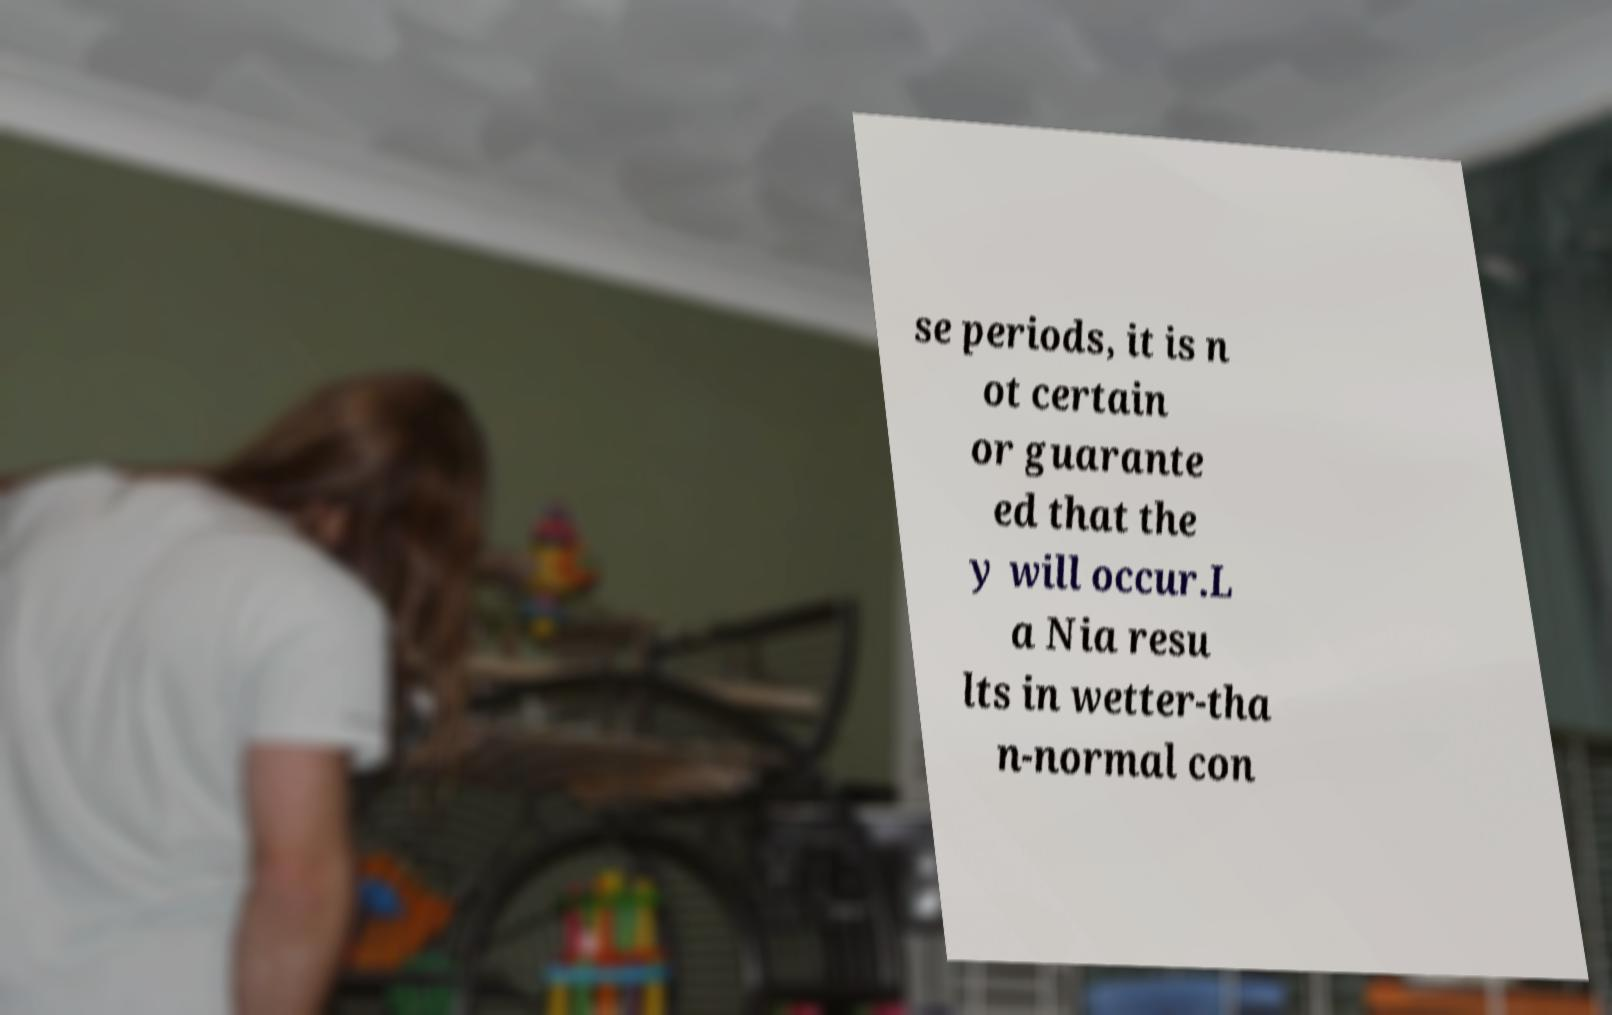For documentation purposes, I need the text within this image transcribed. Could you provide that? se periods, it is n ot certain or guarante ed that the y will occur.L a Nia resu lts in wetter-tha n-normal con 